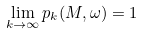<formula> <loc_0><loc_0><loc_500><loc_500>\lim _ { k \to \infty } p _ { k } ( M , \omega ) = 1</formula> 